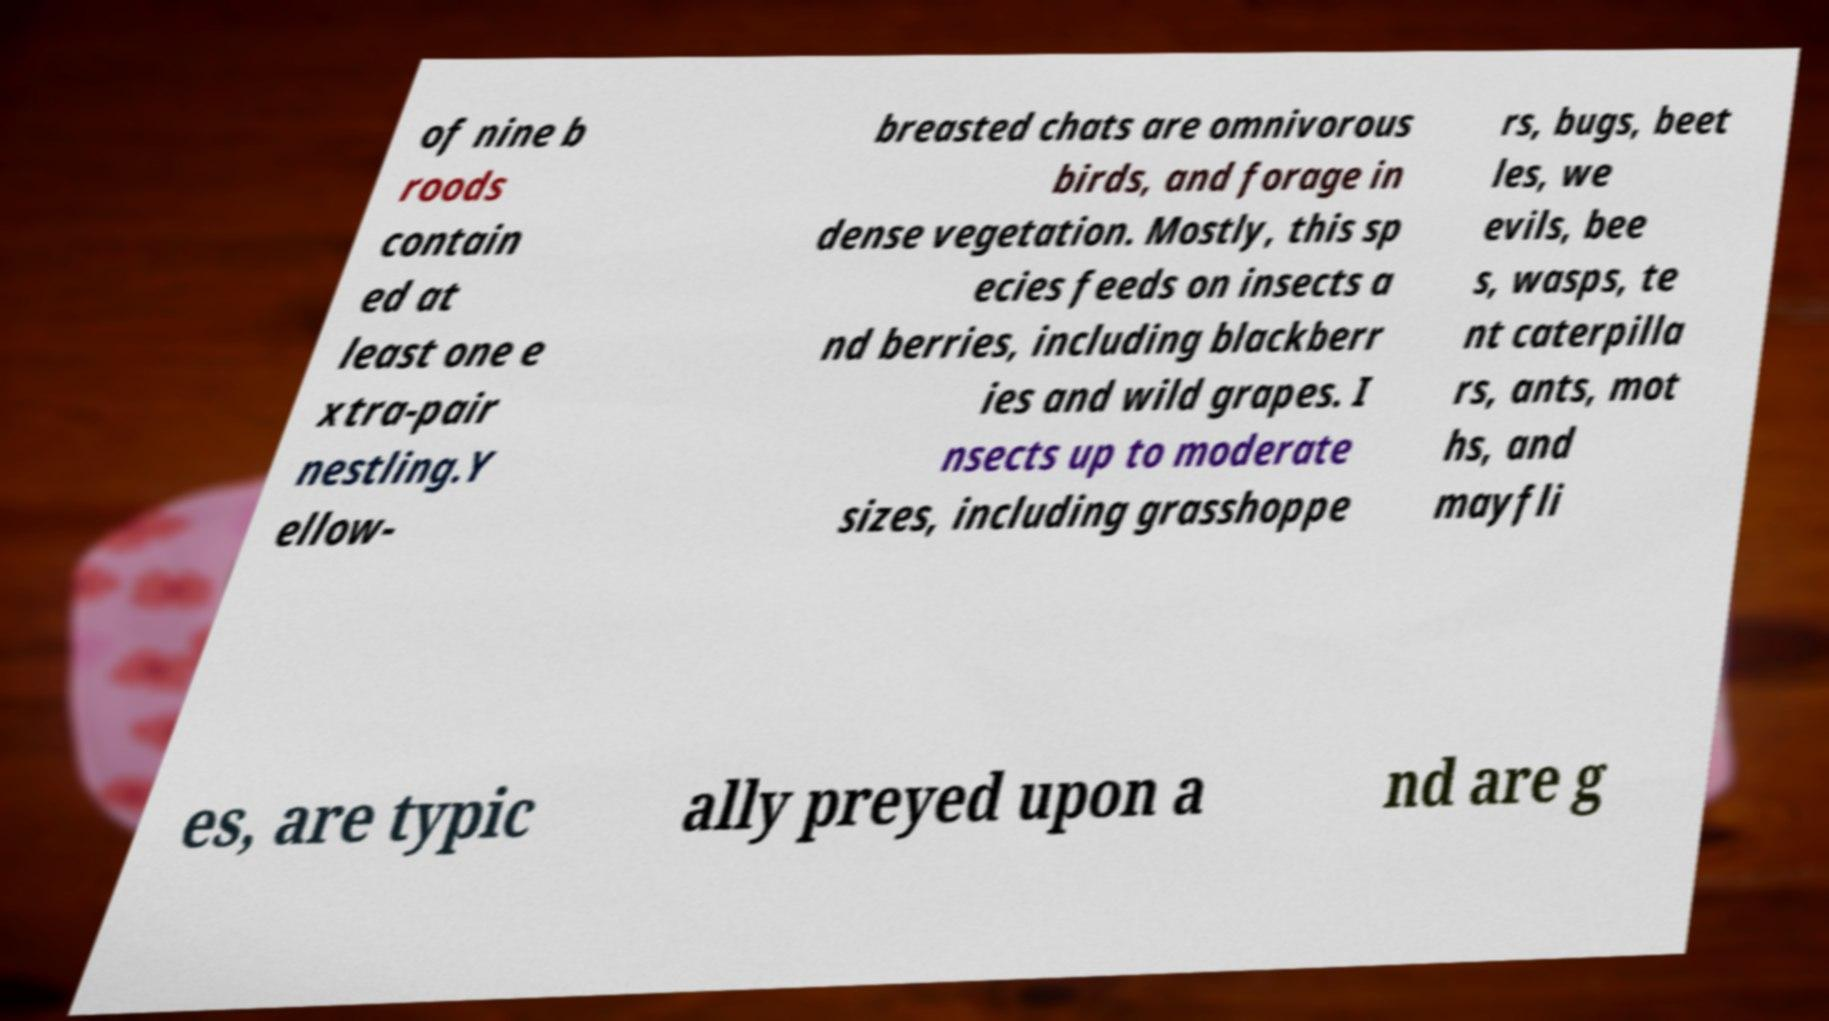Could you extract and type out the text from this image? of nine b roods contain ed at least one e xtra-pair nestling.Y ellow- breasted chats are omnivorous birds, and forage in dense vegetation. Mostly, this sp ecies feeds on insects a nd berries, including blackberr ies and wild grapes. I nsects up to moderate sizes, including grasshoppe rs, bugs, beet les, we evils, bee s, wasps, te nt caterpilla rs, ants, mot hs, and mayfli es, are typic ally preyed upon a nd are g 